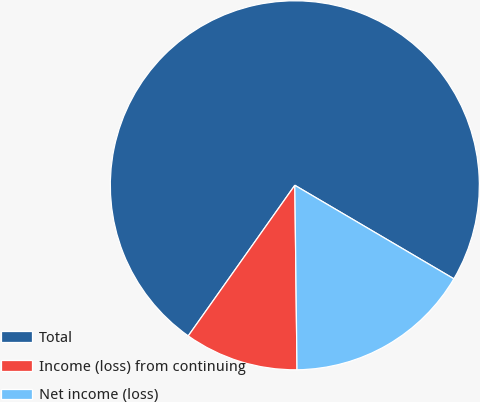Convert chart. <chart><loc_0><loc_0><loc_500><loc_500><pie_chart><fcel>Total<fcel>Income (loss) from continuing<fcel>Net income (loss)<nl><fcel>73.66%<fcel>9.99%<fcel>16.35%<nl></chart> 